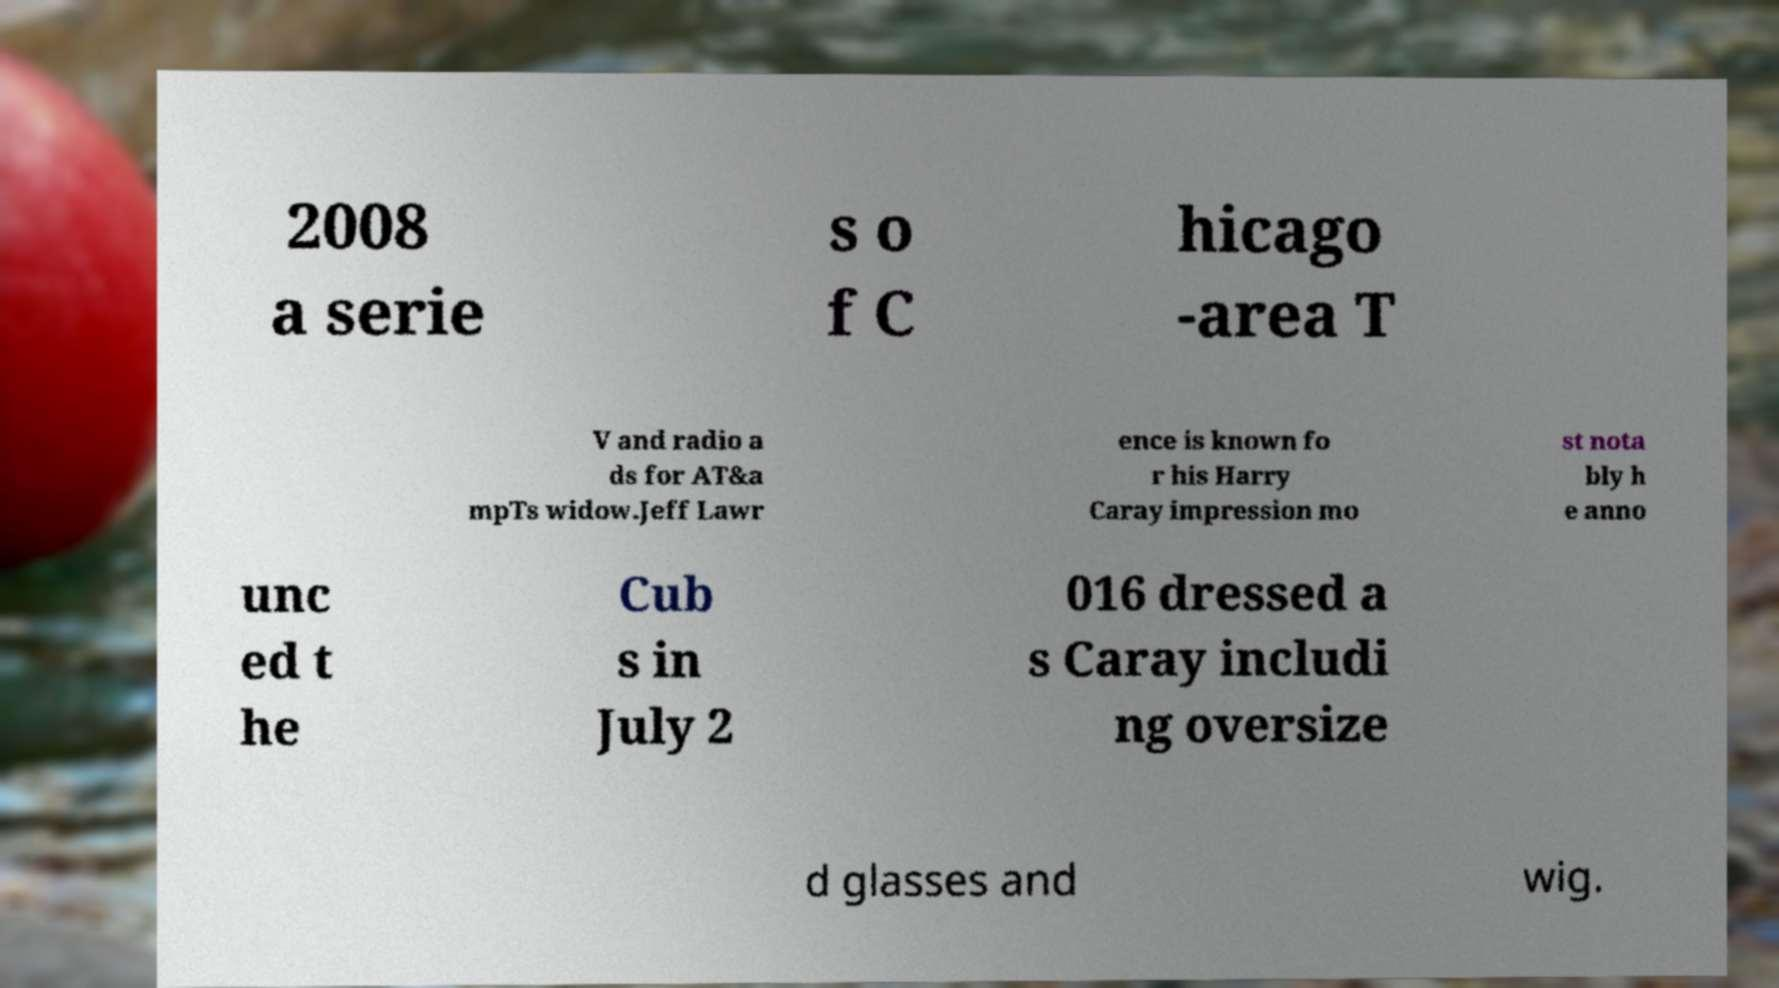For documentation purposes, I need the text within this image transcribed. Could you provide that? 2008 a serie s o f C hicago -area T V and radio a ds for AT&a mpTs widow.Jeff Lawr ence is known fo r his Harry Caray impression mo st nota bly h e anno unc ed t he Cub s in July 2 016 dressed a s Caray includi ng oversize d glasses and wig. 